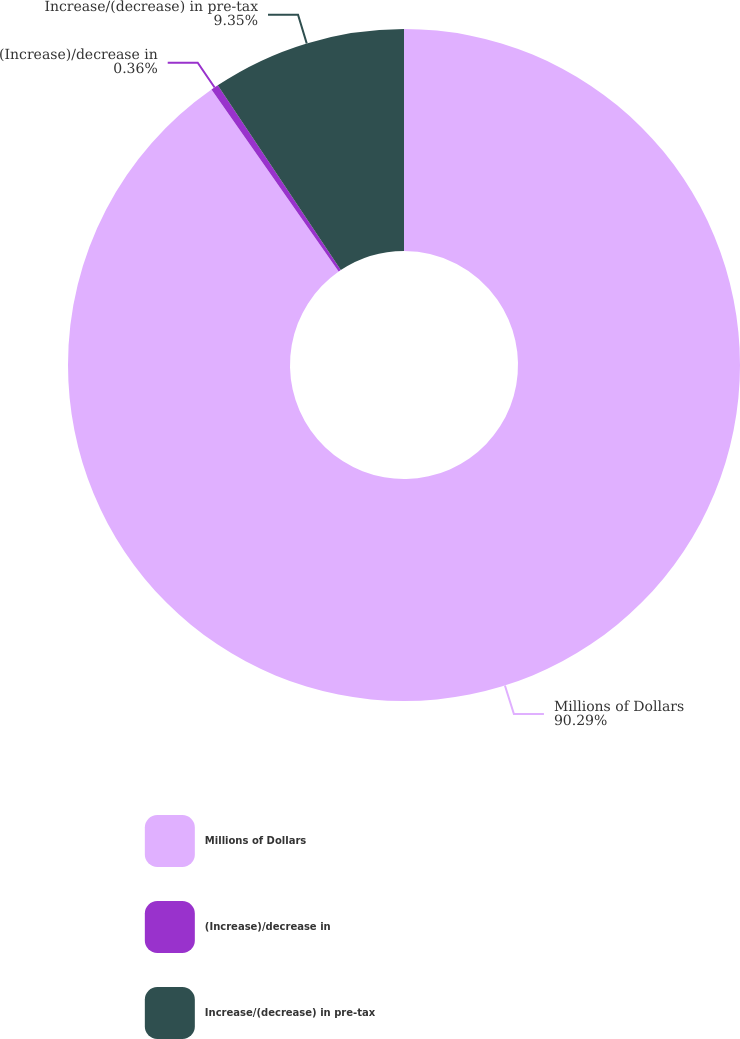Convert chart. <chart><loc_0><loc_0><loc_500><loc_500><pie_chart><fcel>Millions of Dollars<fcel>(Increase)/decrease in<fcel>Increase/(decrease) in pre-tax<nl><fcel>90.29%<fcel>0.36%<fcel>9.35%<nl></chart> 